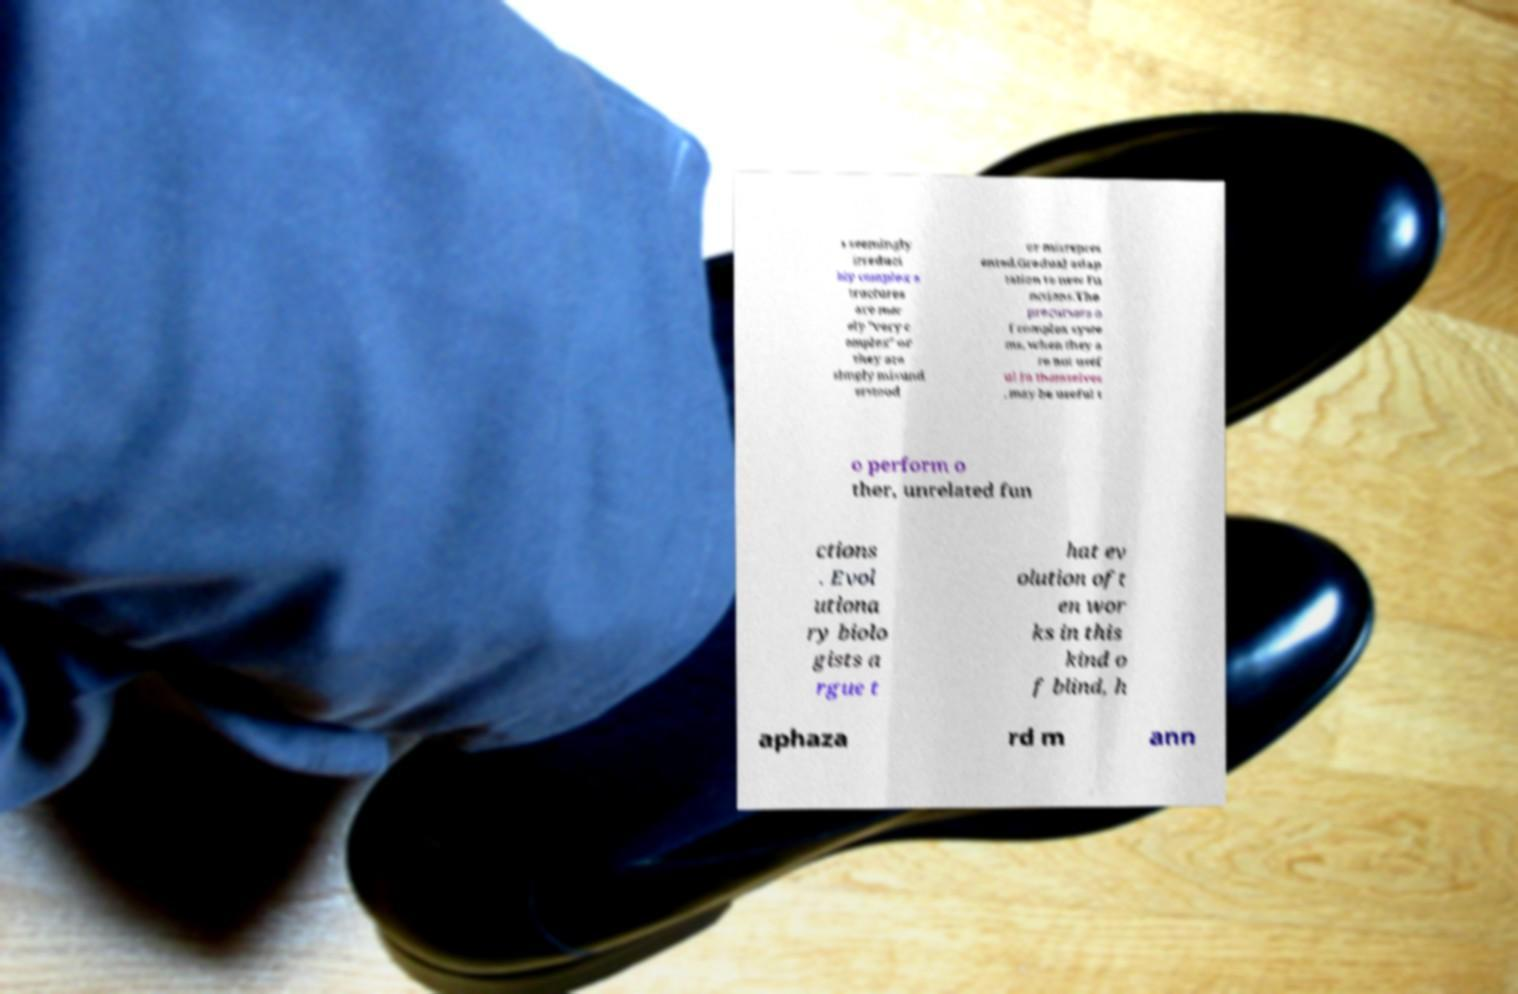I need the written content from this picture converted into text. Can you do that? s seemingly irreduci bly complex s tructures are mer ely "very c omplex" or they are simply misund erstood or misrepres ented.Gradual adap tation to new fu nctions.The precursors o f complex syste ms, when they a re not usef ul in themselves , may be useful t o perform o ther, unrelated fun ctions . Evol utiona ry biolo gists a rgue t hat ev olution oft en wor ks in this kind o f blind, h aphaza rd m ann 